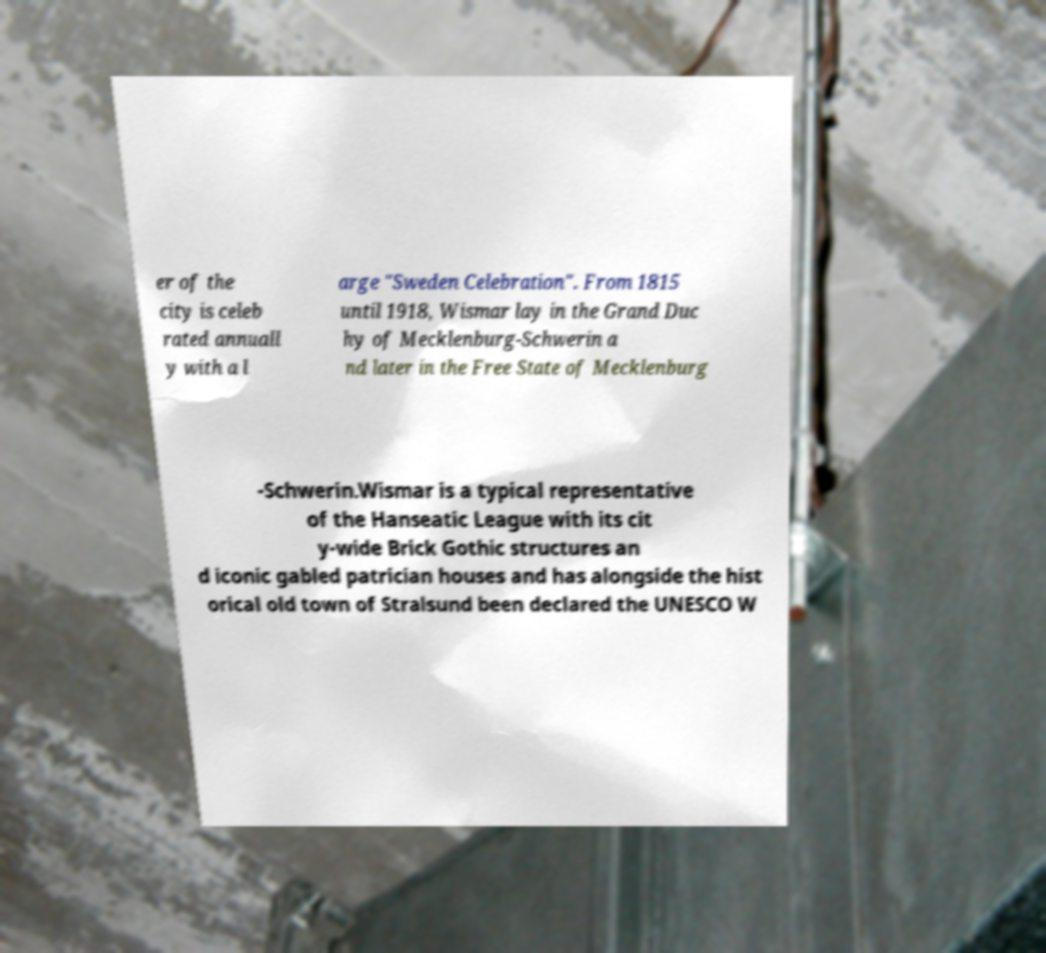There's text embedded in this image that I need extracted. Can you transcribe it verbatim? er of the city is celeb rated annuall y with a l arge "Sweden Celebration". From 1815 until 1918, Wismar lay in the Grand Duc hy of Mecklenburg-Schwerin a nd later in the Free State of Mecklenburg -Schwerin.Wismar is a typical representative of the Hanseatic League with its cit y-wide Brick Gothic structures an d iconic gabled patrician houses and has alongside the hist orical old town of Stralsund been declared the UNESCO W 